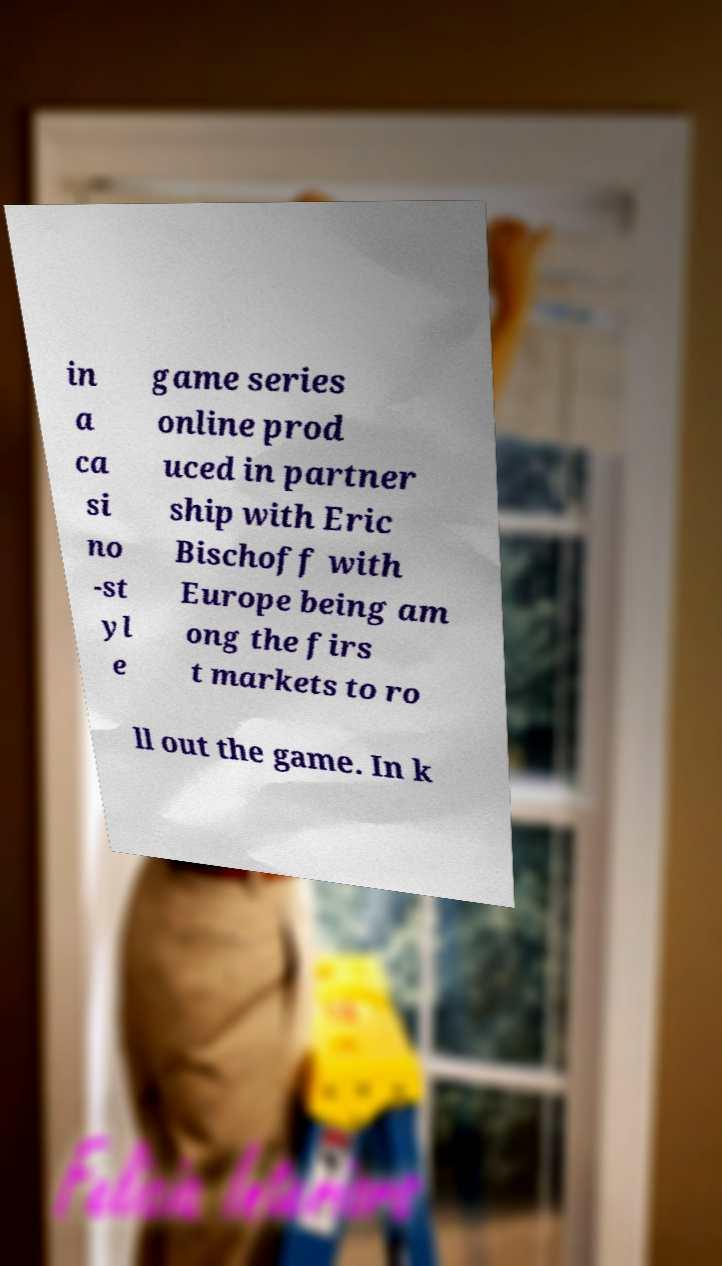Please read and relay the text visible in this image. What does it say? in a ca si no -st yl e game series online prod uced in partner ship with Eric Bischoff with Europe being am ong the firs t markets to ro ll out the game. In k 